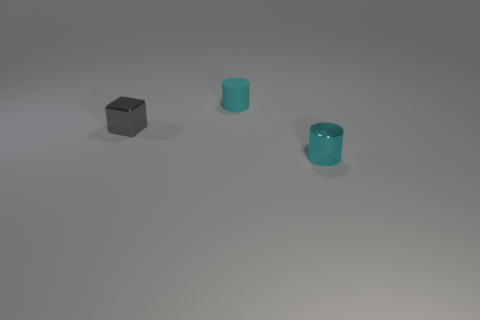Add 2 tiny metal cubes. How many objects exist? 5 Subtract all cylinders. How many objects are left? 1 Subtract all matte objects. Subtract all gray cubes. How many objects are left? 1 Add 3 cyan metal cylinders. How many cyan metal cylinders are left? 4 Add 2 small brown metal objects. How many small brown metal objects exist? 2 Subtract 0 purple spheres. How many objects are left? 3 